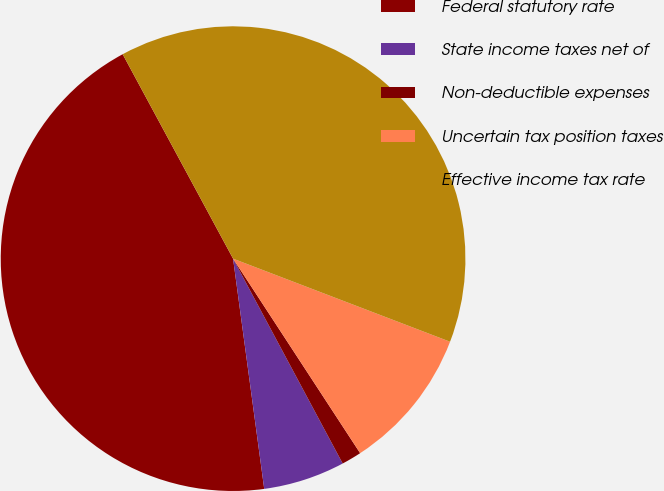<chart> <loc_0><loc_0><loc_500><loc_500><pie_chart><fcel>Federal statutory rate<fcel>State income taxes net of<fcel>Non-deductible expenses<fcel>Uncertain tax position taxes<fcel>Effective income tax rate<nl><fcel>44.26%<fcel>5.68%<fcel>1.39%<fcel>9.97%<fcel>38.7%<nl></chart> 